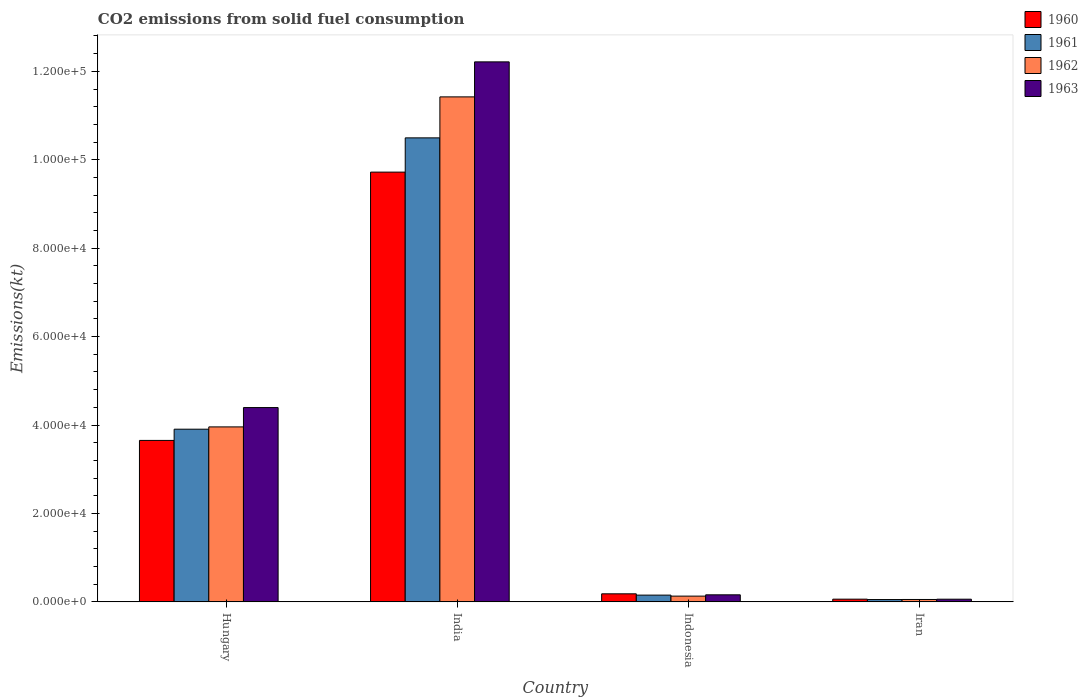How many groups of bars are there?
Your answer should be compact. 4. How many bars are there on the 2nd tick from the left?
Provide a succinct answer. 4. How many bars are there on the 2nd tick from the right?
Your response must be concise. 4. What is the label of the 2nd group of bars from the left?
Your answer should be very brief. India. What is the amount of CO2 emitted in 1960 in Hungary?
Keep it short and to the point. 3.65e+04. Across all countries, what is the maximum amount of CO2 emitted in 1962?
Give a very brief answer. 1.14e+05. Across all countries, what is the minimum amount of CO2 emitted in 1962?
Offer a terse response. 542.72. In which country was the amount of CO2 emitted in 1963 minimum?
Keep it short and to the point. Iran. What is the total amount of CO2 emitted in 1960 in the graph?
Ensure brevity in your answer.  1.36e+05. What is the difference between the amount of CO2 emitted in 1963 in India and that in Indonesia?
Provide a succinct answer. 1.21e+05. What is the difference between the amount of CO2 emitted in 1960 in Indonesia and the amount of CO2 emitted in 1962 in Hungary?
Your answer should be very brief. -3.78e+04. What is the average amount of CO2 emitted in 1963 per country?
Your answer should be very brief. 4.21e+04. What is the difference between the amount of CO2 emitted of/in 1960 and amount of CO2 emitted of/in 1961 in India?
Your response must be concise. -7748.37. In how many countries, is the amount of CO2 emitted in 1963 greater than 28000 kt?
Make the answer very short. 2. What is the ratio of the amount of CO2 emitted in 1961 in Indonesia to that in Iran?
Provide a short and direct response. 2.92. Is the difference between the amount of CO2 emitted in 1960 in Indonesia and Iran greater than the difference between the amount of CO2 emitted in 1961 in Indonesia and Iran?
Your response must be concise. Yes. What is the difference between the highest and the second highest amount of CO2 emitted in 1960?
Offer a very short reply. 9.54e+04. What is the difference between the highest and the lowest amount of CO2 emitted in 1962?
Provide a succinct answer. 1.14e+05. In how many countries, is the amount of CO2 emitted in 1963 greater than the average amount of CO2 emitted in 1963 taken over all countries?
Your answer should be very brief. 2. What does the 3rd bar from the left in Hungary represents?
Provide a succinct answer. 1962. What does the 4th bar from the right in Indonesia represents?
Your response must be concise. 1960. Is it the case that in every country, the sum of the amount of CO2 emitted in 1962 and amount of CO2 emitted in 1960 is greater than the amount of CO2 emitted in 1961?
Offer a very short reply. Yes. How many bars are there?
Provide a succinct answer. 16. How many countries are there in the graph?
Make the answer very short. 4. Are the values on the major ticks of Y-axis written in scientific E-notation?
Your answer should be very brief. Yes. Does the graph contain any zero values?
Make the answer very short. No. Does the graph contain grids?
Your answer should be very brief. No. Where does the legend appear in the graph?
Your response must be concise. Top right. How many legend labels are there?
Offer a terse response. 4. What is the title of the graph?
Offer a terse response. CO2 emissions from solid fuel consumption. Does "1975" appear as one of the legend labels in the graph?
Your answer should be compact. No. What is the label or title of the X-axis?
Keep it short and to the point. Country. What is the label or title of the Y-axis?
Keep it short and to the point. Emissions(kt). What is the Emissions(kt) of 1960 in Hungary?
Your response must be concise. 3.65e+04. What is the Emissions(kt) in 1961 in Hungary?
Offer a terse response. 3.91e+04. What is the Emissions(kt) in 1962 in Hungary?
Your answer should be very brief. 3.96e+04. What is the Emissions(kt) of 1963 in Hungary?
Make the answer very short. 4.39e+04. What is the Emissions(kt) in 1960 in India?
Make the answer very short. 9.72e+04. What is the Emissions(kt) in 1961 in India?
Offer a terse response. 1.05e+05. What is the Emissions(kt) in 1962 in India?
Offer a terse response. 1.14e+05. What is the Emissions(kt) in 1963 in India?
Make the answer very short. 1.22e+05. What is the Emissions(kt) of 1960 in Indonesia?
Your response must be concise. 1822.5. What is the Emissions(kt) of 1961 in Indonesia?
Provide a short and direct response. 1529.14. What is the Emissions(kt) of 1962 in Indonesia?
Your answer should be compact. 1301.79. What is the Emissions(kt) in 1963 in Indonesia?
Your response must be concise. 1595.14. What is the Emissions(kt) in 1960 in Iran?
Offer a terse response. 612.39. What is the Emissions(kt) of 1961 in Iran?
Provide a succinct answer. 524.38. What is the Emissions(kt) of 1962 in Iran?
Keep it short and to the point. 542.72. What is the Emissions(kt) in 1963 in Iran?
Your answer should be compact. 605.05. Across all countries, what is the maximum Emissions(kt) in 1960?
Offer a terse response. 9.72e+04. Across all countries, what is the maximum Emissions(kt) in 1961?
Ensure brevity in your answer.  1.05e+05. Across all countries, what is the maximum Emissions(kt) of 1962?
Make the answer very short. 1.14e+05. Across all countries, what is the maximum Emissions(kt) of 1963?
Offer a terse response. 1.22e+05. Across all countries, what is the minimum Emissions(kt) in 1960?
Your response must be concise. 612.39. Across all countries, what is the minimum Emissions(kt) in 1961?
Keep it short and to the point. 524.38. Across all countries, what is the minimum Emissions(kt) in 1962?
Your answer should be compact. 542.72. Across all countries, what is the minimum Emissions(kt) in 1963?
Make the answer very short. 605.05. What is the total Emissions(kt) of 1960 in the graph?
Make the answer very short. 1.36e+05. What is the total Emissions(kt) in 1961 in the graph?
Give a very brief answer. 1.46e+05. What is the total Emissions(kt) in 1962 in the graph?
Your answer should be compact. 1.56e+05. What is the total Emissions(kt) of 1963 in the graph?
Provide a short and direct response. 1.68e+05. What is the difference between the Emissions(kt) in 1960 in Hungary and that in India?
Your response must be concise. -6.07e+04. What is the difference between the Emissions(kt) of 1961 in Hungary and that in India?
Your answer should be very brief. -6.59e+04. What is the difference between the Emissions(kt) of 1962 in Hungary and that in India?
Your answer should be very brief. -7.46e+04. What is the difference between the Emissions(kt) in 1963 in Hungary and that in India?
Your answer should be compact. -7.82e+04. What is the difference between the Emissions(kt) of 1960 in Hungary and that in Indonesia?
Your response must be concise. 3.47e+04. What is the difference between the Emissions(kt) in 1961 in Hungary and that in Indonesia?
Your answer should be very brief. 3.75e+04. What is the difference between the Emissions(kt) in 1962 in Hungary and that in Indonesia?
Offer a terse response. 3.83e+04. What is the difference between the Emissions(kt) of 1963 in Hungary and that in Indonesia?
Make the answer very short. 4.24e+04. What is the difference between the Emissions(kt) in 1960 in Hungary and that in Iran?
Provide a short and direct response. 3.59e+04. What is the difference between the Emissions(kt) of 1961 in Hungary and that in Iran?
Provide a succinct answer. 3.85e+04. What is the difference between the Emissions(kt) of 1962 in Hungary and that in Iran?
Provide a succinct answer. 3.90e+04. What is the difference between the Emissions(kt) in 1963 in Hungary and that in Iran?
Provide a short and direct response. 4.33e+04. What is the difference between the Emissions(kt) of 1960 in India and that in Indonesia?
Provide a short and direct response. 9.54e+04. What is the difference between the Emissions(kt) of 1961 in India and that in Indonesia?
Your answer should be very brief. 1.03e+05. What is the difference between the Emissions(kt) in 1962 in India and that in Indonesia?
Your answer should be very brief. 1.13e+05. What is the difference between the Emissions(kt) of 1963 in India and that in Indonesia?
Your response must be concise. 1.21e+05. What is the difference between the Emissions(kt) in 1960 in India and that in Iran?
Offer a terse response. 9.66e+04. What is the difference between the Emissions(kt) of 1961 in India and that in Iran?
Keep it short and to the point. 1.04e+05. What is the difference between the Emissions(kt) in 1962 in India and that in Iran?
Provide a succinct answer. 1.14e+05. What is the difference between the Emissions(kt) in 1963 in India and that in Iran?
Offer a terse response. 1.22e+05. What is the difference between the Emissions(kt) in 1960 in Indonesia and that in Iran?
Give a very brief answer. 1210.11. What is the difference between the Emissions(kt) in 1961 in Indonesia and that in Iran?
Offer a very short reply. 1004.76. What is the difference between the Emissions(kt) of 1962 in Indonesia and that in Iran?
Keep it short and to the point. 759.07. What is the difference between the Emissions(kt) in 1963 in Indonesia and that in Iran?
Your response must be concise. 990.09. What is the difference between the Emissions(kt) of 1960 in Hungary and the Emissions(kt) of 1961 in India?
Provide a short and direct response. -6.84e+04. What is the difference between the Emissions(kt) in 1960 in Hungary and the Emissions(kt) in 1962 in India?
Offer a terse response. -7.77e+04. What is the difference between the Emissions(kt) in 1960 in Hungary and the Emissions(kt) in 1963 in India?
Give a very brief answer. -8.56e+04. What is the difference between the Emissions(kt) in 1961 in Hungary and the Emissions(kt) in 1962 in India?
Provide a short and direct response. -7.52e+04. What is the difference between the Emissions(kt) in 1961 in Hungary and the Emissions(kt) in 1963 in India?
Offer a terse response. -8.31e+04. What is the difference between the Emissions(kt) of 1962 in Hungary and the Emissions(kt) of 1963 in India?
Provide a succinct answer. -8.26e+04. What is the difference between the Emissions(kt) in 1960 in Hungary and the Emissions(kt) in 1961 in Indonesia?
Your response must be concise. 3.50e+04. What is the difference between the Emissions(kt) of 1960 in Hungary and the Emissions(kt) of 1962 in Indonesia?
Give a very brief answer. 3.52e+04. What is the difference between the Emissions(kt) in 1960 in Hungary and the Emissions(kt) in 1963 in Indonesia?
Offer a very short reply. 3.49e+04. What is the difference between the Emissions(kt) in 1961 in Hungary and the Emissions(kt) in 1962 in Indonesia?
Offer a very short reply. 3.78e+04. What is the difference between the Emissions(kt) in 1961 in Hungary and the Emissions(kt) in 1963 in Indonesia?
Offer a terse response. 3.75e+04. What is the difference between the Emissions(kt) of 1962 in Hungary and the Emissions(kt) of 1963 in Indonesia?
Your response must be concise. 3.80e+04. What is the difference between the Emissions(kt) in 1960 in Hungary and the Emissions(kt) in 1961 in Iran?
Make the answer very short. 3.60e+04. What is the difference between the Emissions(kt) in 1960 in Hungary and the Emissions(kt) in 1962 in Iran?
Offer a terse response. 3.60e+04. What is the difference between the Emissions(kt) of 1960 in Hungary and the Emissions(kt) of 1963 in Iran?
Offer a very short reply. 3.59e+04. What is the difference between the Emissions(kt) in 1961 in Hungary and the Emissions(kt) in 1962 in Iran?
Your answer should be very brief. 3.85e+04. What is the difference between the Emissions(kt) in 1961 in Hungary and the Emissions(kt) in 1963 in Iran?
Give a very brief answer. 3.85e+04. What is the difference between the Emissions(kt) in 1962 in Hungary and the Emissions(kt) in 1963 in Iran?
Provide a succinct answer. 3.90e+04. What is the difference between the Emissions(kt) in 1960 in India and the Emissions(kt) in 1961 in Indonesia?
Make the answer very short. 9.57e+04. What is the difference between the Emissions(kt) of 1960 in India and the Emissions(kt) of 1962 in Indonesia?
Make the answer very short. 9.59e+04. What is the difference between the Emissions(kt) of 1960 in India and the Emissions(kt) of 1963 in Indonesia?
Offer a very short reply. 9.56e+04. What is the difference between the Emissions(kt) of 1961 in India and the Emissions(kt) of 1962 in Indonesia?
Give a very brief answer. 1.04e+05. What is the difference between the Emissions(kt) of 1961 in India and the Emissions(kt) of 1963 in Indonesia?
Your response must be concise. 1.03e+05. What is the difference between the Emissions(kt) in 1962 in India and the Emissions(kt) in 1963 in Indonesia?
Your answer should be compact. 1.13e+05. What is the difference between the Emissions(kt) in 1960 in India and the Emissions(kt) in 1961 in Iran?
Your answer should be compact. 9.67e+04. What is the difference between the Emissions(kt) in 1960 in India and the Emissions(kt) in 1962 in Iran?
Give a very brief answer. 9.67e+04. What is the difference between the Emissions(kt) in 1960 in India and the Emissions(kt) in 1963 in Iran?
Give a very brief answer. 9.66e+04. What is the difference between the Emissions(kt) of 1961 in India and the Emissions(kt) of 1962 in Iran?
Keep it short and to the point. 1.04e+05. What is the difference between the Emissions(kt) in 1961 in India and the Emissions(kt) in 1963 in Iran?
Keep it short and to the point. 1.04e+05. What is the difference between the Emissions(kt) in 1962 in India and the Emissions(kt) in 1963 in Iran?
Keep it short and to the point. 1.14e+05. What is the difference between the Emissions(kt) in 1960 in Indonesia and the Emissions(kt) in 1961 in Iran?
Keep it short and to the point. 1298.12. What is the difference between the Emissions(kt) in 1960 in Indonesia and the Emissions(kt) in 1962 in Iran?
Your answer should be very brief. 1279.78. What is the difference between the Emissions(kt) of 1960 in Indonesia and the Emissions(kt) of 1963 in Iran?
Make the answer very short. 1217.44. What is the difference between the Emissions(kt) in 1961 in Indonesia and the Emissions(kt) in 1962 in Iran?
Provide a short and direct response. 986.42. What is the difference between the Emissions(kt) in 1961 in Indonesia and the Emissions(kt) in 1963 in Iran?
Provide a succinct answer. 924.08. What is the difference between the Emissions(kt) of 1962 in Indonesia and the Emissions(kt) of 1963 in Iran?
Make the answer very short. 696.73. What is the average Emissions(kt) of 1960 per country?
Your response must be concise. 3.40e+04. What is the average Emissions(kt) of 1961 per country?
Provide a short and direct response. 3.65e+04. What is the average Emissions(kt) of 1962 per country?
Your answer should be very brief. 3.89e+04. What is the average Emissions(kt) of 1963 per country?
Offer a very short reply. 4.21e+04. What is the difference between the Emissions(kt) of 1960 and Emissions(kt) of 1961 in Hungary?
Make the answer very short. -2537.56. What is the difference between the Emissions(kt) in 1960 and Emissions(kt) in 1962 in Hungary?
Ensure brevity in your answer.  -3058.28. What is the difference between the Emissions(kt) in 1960 and Emissions(kt) in 1963 in Hungary?
Your response must be concise. -7429.34. What is the difference between the Emissions(kt) in 1961 and Emissions(kt) in 1962 in Hungary?
Your answer should be compact. -520.71. What is the difference between the Emissions(kt) of 1961 and Emissions(kt) of 1963 in Hungary?
Offer a terse response. -4891.78. What is the difference between the Emissions(kt) of 1962 and Emissions(kt) of 1963 in Hungary?
Provide a short and direct response. -4371.06. What is the difference between the Emissions(kt) in 1960 and Emissions(kt) in 1961 in India?
Provide a succinct answer. -7748.37. What is the difference between the Emissions(kt) in 1960 and Emissions(kt) in 1962 in India?
Make the answer very short. -1.70e+04. What is the difference between the Emissions(kt) in 1960 and Emissions(kt) in 1963 in India?
Provide a succinct answer. -2.49e+04. What is the difference between the Emissions(kt) in 1961 and Emissions(kt) in 1962 in India?
Make the answer very short. -9270.18. What is the difference between the Emissions(kt) in 1961 and Emissions(kt) in 1963 in India?
Give a very brief answer. -1.72e+04. What is the difference between the Emissions(kt) in 1962 and Emissions(kt) in 1963 in India?
Provide a succinct answer. -7917.05. What is the difference between the Emissions(kt) of 1960 and Emissions(kt) of 1961 in Indonesia?
Your answer should be very brief. 293.36. What is the difference between the Emissions(kt) in 1960 and Emissions(kt) in 1962 in Indonesia?
Your answer should be very brief. 520.71. What is the difference between the Emissions(kt) in 1960 and Emissions(kt) in 1963 in Indonesia?
Ensure brevity in your answer.  227.35. What is the difference between the Emissions(kt) in 1961 and Emissions(kt) in 1962 in Indonesia?
Your response must be concise. 227.35. What is the difference between the Emissions(kt) of 1961 and Emissions(kt) of 1963 in Indonesia?
Offer a terse response. -66.01. What is the difference between the Emissions(kt) of 1962 and Emissions(kt) of 1963 in Indonesia?
Make the answer very short. -293.36. What is the difference between the Emissions(kt) in 1960 and Emissions(kt) in 1961 in Iran?
Give a very brief answer. 88.01. What is the difference between the Emissions(kt) of 1960 and Emissions(kt) of 1962 in Iran?
Your answer should be compact. 69.67. What is the difference between the Emissions(kt) in 1960 and Emissions(kt) in 1963 in Iran?
Provide a short and direct response. 7.33. What is the difference between the Emissions(kt) in 1961 and Emissions(kt) in 1962 in Iran?
Your response must be concise. -18.34. What is the difference between the Emissions(kt) in 1961 and Emissions(kt) in 1963 in Iran?
Your response must be concise. -80.67. What is the difference between the Emissions(kt) in 1962 and Emissions(kt) in 1963 in Iran?
Your answer should be very brief. -62.34. What is the ratio of the Emissions(kt) of 1960 in Hungary to that in India?
Provide a short and direct response. 0.38. What is the ratio of the Emissions(kt) in 1961 in Hungary to that in India?
Provide a succinct answer. 0.37. What is the ratio of the Emissions(kt) in 1962 in Hungary to that in India?
Your answer should be very brief. 0.35. What is the ratio of the Emissions(kt) in 1963 in Hungary to that in India?
Your answer should be compact. 0.36. What is the ratio of the Emissions(kt) of 1960 in Hungary to that in Indonesia?
Provide a succinct answer. 20.04. What is the ratio of the Emissions(kt) of 1961 in Hungary to that in Indonesia?
Provide a succinct answer. 25.54. What is the ratio of the Emissions(kt) in 1962 in Hungary to that in Indonesia?
Offer a terse response. 30.4. What is the ratio of the Emissions(kt) of 1963 in Hungary to that in Indonesia?
Make the answer very short. 27.55. What is the ratio of the Emissions(kt) in 1960 in Hungary to that in Iran?
Make the answer very short. 59.63. What is the ratio of the Emissions(kt) in 1961 in Hungary to that in Iran?
Provide a succinct answer. 74.48. What is the ratio of the Emissions(kt) of 1962 in Hungary to that in Iran?
Provide a succinct answer. 72.93. What is the ratio of the Emissions(kt) in 1963 in Hungary to that in Iran?
Give a very brief answer. 72.64. What is the ratio of the Emissions(kt) of 1960 in India to that in Indonesia?
Keep it short and to the point. 53.34. What is the ratio of the Emissions(kt) in 1961 in India to that in Indonesia?
Provide a succinct answer. 68.64. What is the ratio of the Emissions(kt) of 1962 in India to that in Indonesia?
Give a very brief answer. 87.75. What is the ratio of the Emissions(kt) in 1963 in India to that in Indonesia?
Give a very brief answer. 76.57. What is the ratio of the Emissions(kt) of 1960 in India to that in Iran?
Provide a succinct answer. 158.74. What is the ratio of the Emissions(kt) of 1961 in India to that in Iran?
Make the answer very short. 200.15. What is the ratio of the Emissions(kt) of 1962 in India to that in Iran?
Provide a succinct answer. 210.47. What is the ratio of the Emissions(kt) of 1963 in India to that in Iran?
Your answer should be very brief. 201.87. What is the ratio of the Emissions(kt) in 1960 in Indonesia to that in Iran?
Your answer should be very brief. 2.98. What is the ratio of the Emissions(kt) of 1961 in Indonesia to that in Iran?
Offer a terse response. 2.92. What is the ratio of the Emissions(kt) of 1962 in Indonesia to that in Iran?
Ensure brevity in your answer.  2.4. What is the ratio of the Emissions(kt) of 1963 in Indonesia to that in Iran?
Give a very brief answer. 2.64. What is the difference between the highest and the second highest Emissions(kt) in 1960?
Make the answer very short. 6.07e+04. What is the difference between the highest and the second highest Emissions(kt) in 1961?
Provide a short and direct response. 6.59e+04. What is the difference between the highest and the second highest Emissions(kt) of 1962?
Ensure brevity in your answer.  7.46e+04. What is the difference between the highest and the second highest Emissions(kt) of 1963?
Ensure brevity in your answer.  7.82e+04. What is the difference between the highest and the lowest Emissions(kt) of 1960?
Ensure brevity in your answer.  9.66e+04. What is the difference between the highest and the lowest Emissions(kt) in 1961?
Your answer should be compact. 1.04e+05. What is the difference between the highest and the lowest Emissions(kt) in 1962?
Provide a short and direct response. 1.14e+05. What is the difference between the highest and the lowest Emissions(kt) of 1963?
Give a very brief answer. 1.22e+05. 